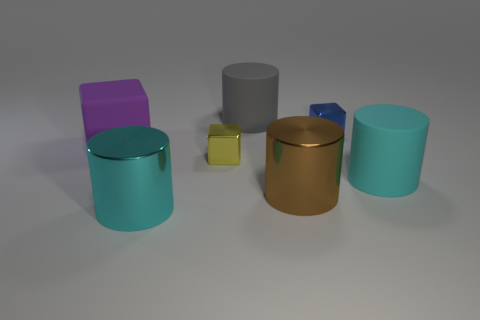Add 1 big gray objects. How many objects exist? 8 Subtract all cylinders. How many objects are left? 3 Subtract 0 blue balls. How many objects are left? 7 Subtract all yellow rubber things. Subtract all large cyan cylinders. How many objects are left? 5 Add 5 large matte things. How many large matte things are left? 8 Add 6 cyan cylinders. How many cyan cylinders exist? 8 